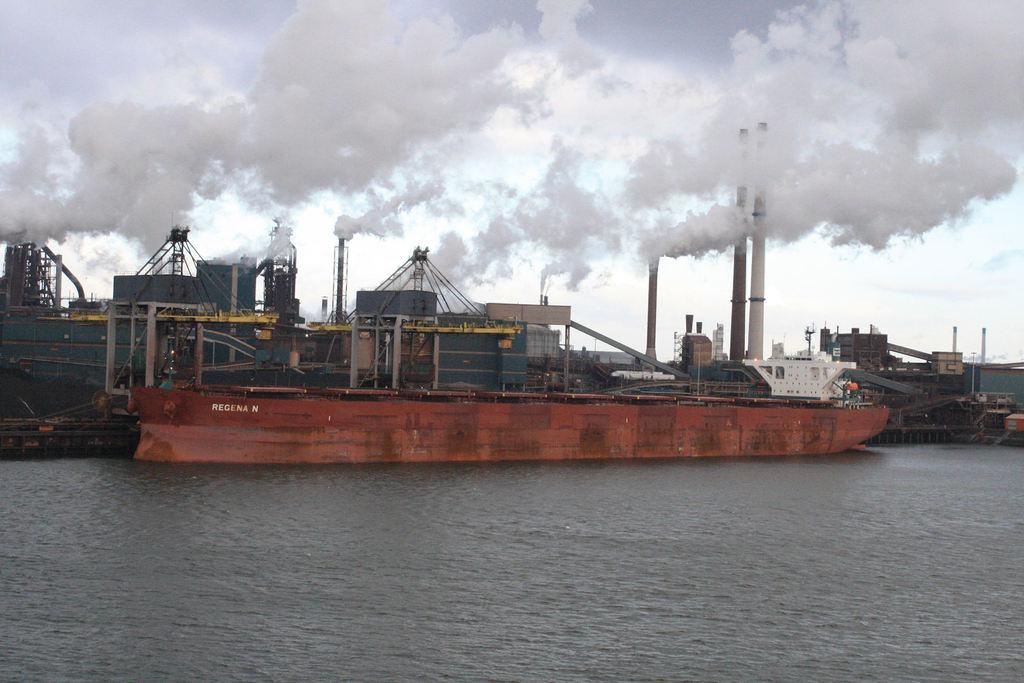What is the main subject of the image? The main subject of the image is many ships. What colors can be seen on the ships? The ships are in white, brown, and grey colors. Where are the ships located? The ships are on the water. What can be seen in the background of the image? There is smoke and clouds visible in the background of the image, and the sky is white. What type of shoe is the boy wearing in the image? There is no boy or shoe present in the image; it features many ships on the water. 